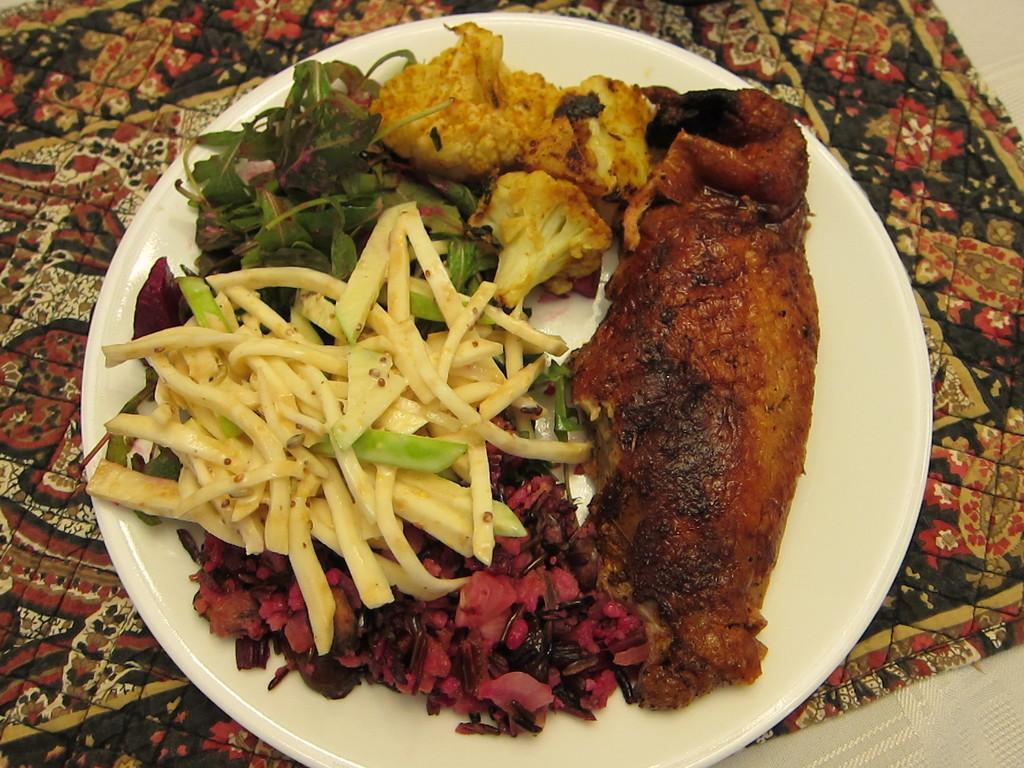In one or two sentences, can you explain what this image depicts? In this image I can see food items on a plate, which is placed on a table mat or on a cloth. 